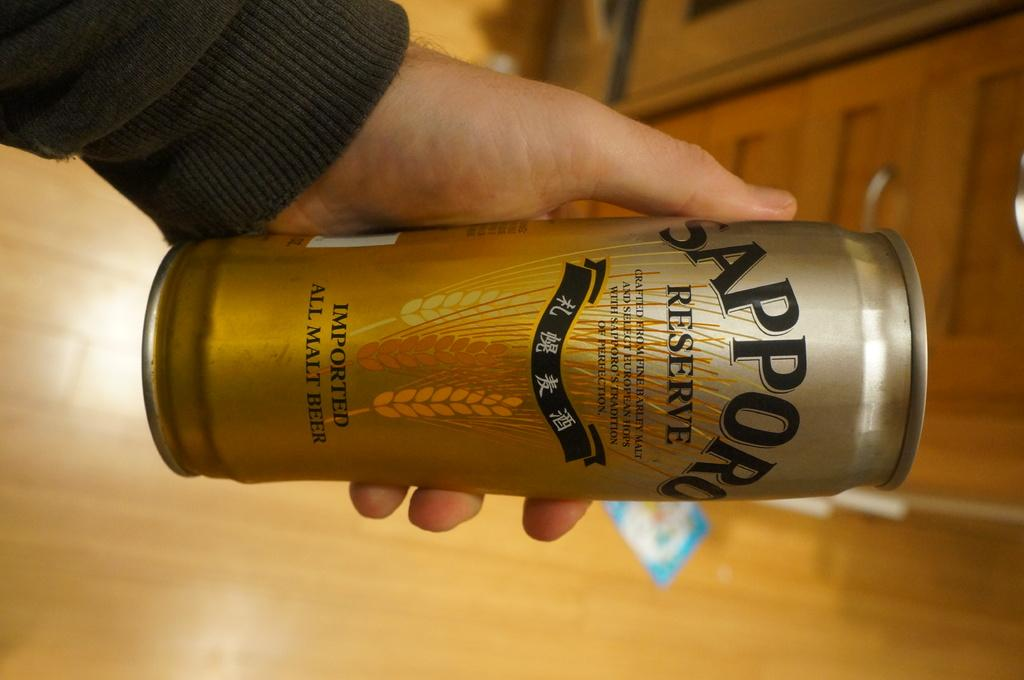<image>
Present a compact description of the photo's key features. A can of Sapporo malt beer is being held in a person's hand. 